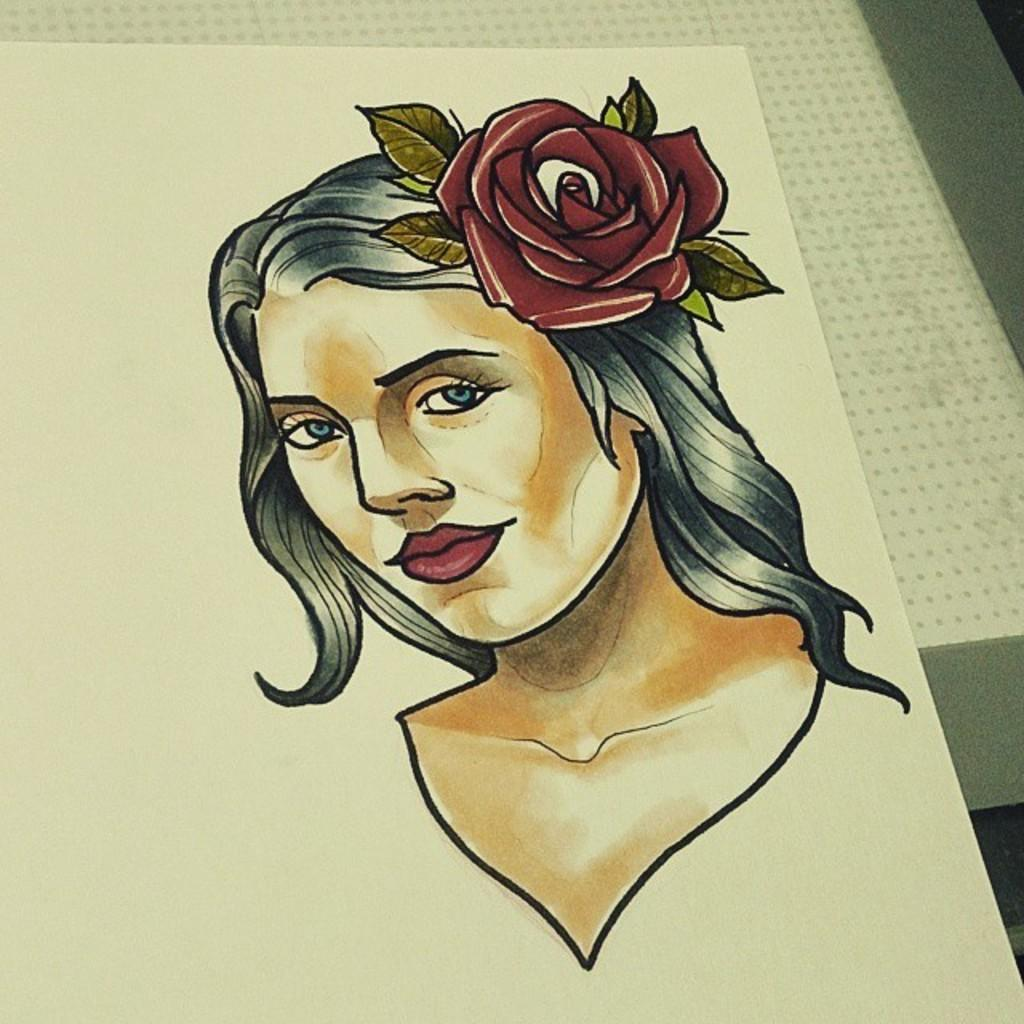What is depicted in the image? There is a drawing of a person in the image. What is the drawing on? The drawing is on a white sheet. Where is the white sheet placed? The sheet is placed on a surface. How many dogs are present in the image? There are no dogs present in the image; it features a drawing of a person on a white sheet. What type of stick is being used by the person in the image? There is no stick present in the image; it is a drawing of a person on a white sheet. 